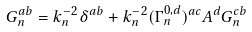Convert formula to latex. <formula><loc_0><loc_0><loc_500><loc_500>G _ { n } ^ { a b } = k _ { n } ^ { - 2 } \delta ^ { a b } + k _ { n } ^ { - 2 } ( \Gamma _ { n } ^ { 0 , d } ) ^ { a c } A ^ { d } G _ { n } ^ { c b } \,</formula> 